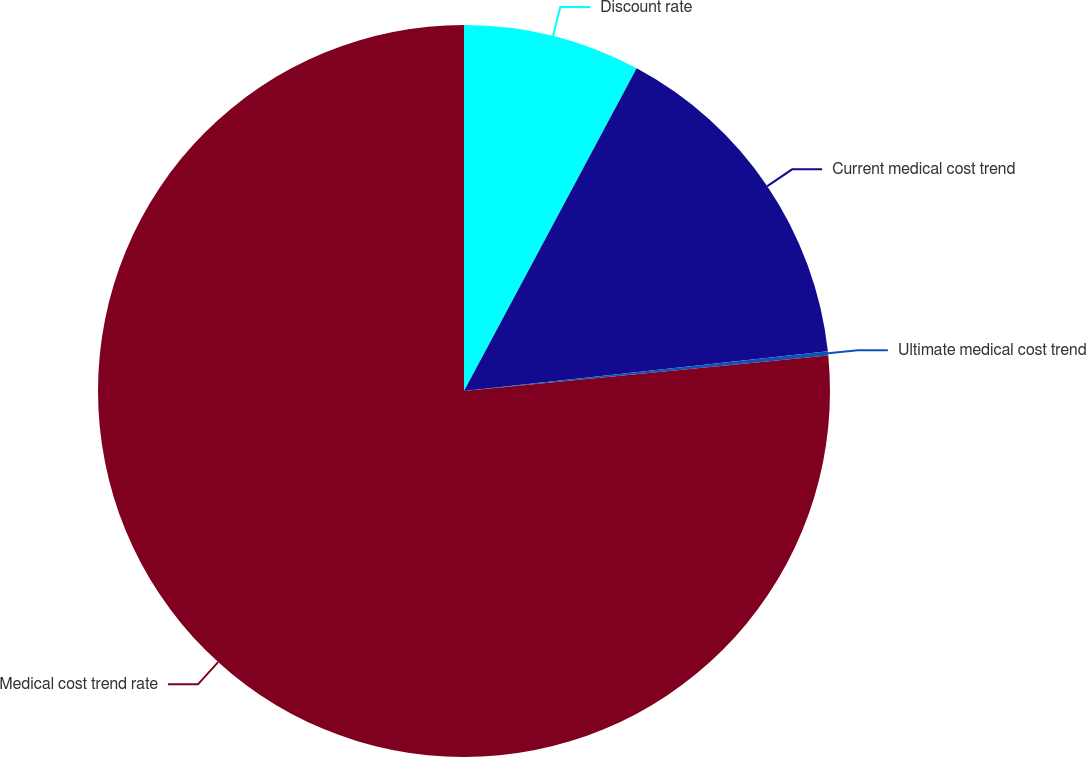<chart> <loc_0><loc_0><loc_500><loc_500><pie_chart><fcel>Discount rate<fcel>Current medical cost trend<fcel>Ultimate medical cost trend<fcel>Medical cost trend rate<nl><fcel>7.82%<fcel>15.45%<fcel>0.18%<fcel>76.55%<nl></chart> 